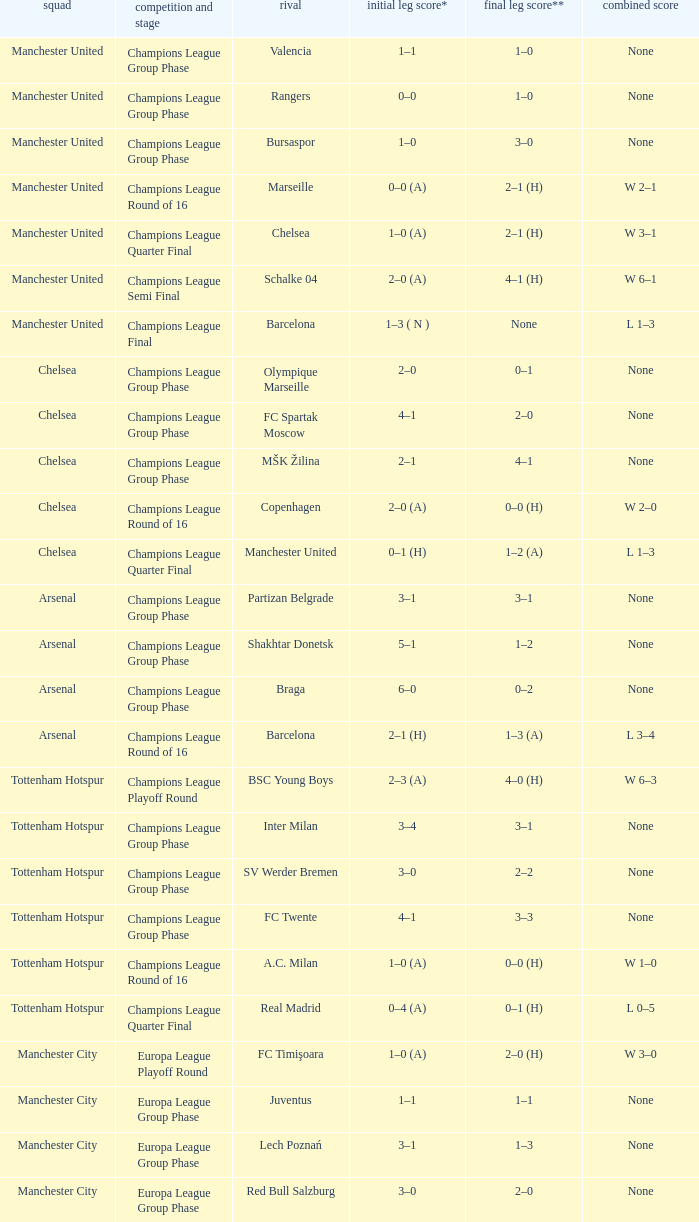Would you mind parsing the complete table? {'header': ['squad', 'competition and stage', 'rival', 'initial leg score*', 'final leg score**', 'combined score'], 'rows': [['Manchester United', 'Champions League Group Phase', 'Valencia', '1–1', '1–0', 'None'], ['Manchester United', 'Champions League Group Phase', 'Rangers', '0–0', '1–0', 'None'], ['Manchester United', 'Champions League Group Phase', 'Bursaspor', '1–0', '3–0', 'None'], ['Manchester United', 'Champions League Round of 16', 'Marseille', '0–0 (A)', '2–1 (H)', 'W 2–1'], ['Manchester United', 'Champions League Quarter Final', 'Chelsea', '1–0 (A)', '2–1 (H)', 'W 3–1'], ['Manchester United', 'Champions League Semi Final', 'Schalke 04', '2–0 (A)', '4–1 (H)', 'W 6–1'], ['Manchester United', 'Champions League Final', 'Barcelona', '1–3 ( N )', 'None', 'L 1–3'], ['Chelsea', 'Champions League Group Phase', 'Olympique Marseille', '2–0', '0–1', 'None'], ['Chelsea', 'Champions League Group Phase', 'FC Spartak Moscow', '4–1', '2–0', 'None'], ['Chelsea', 'Champions League Group Phase', 'MŠK Žilina', '2–1', '4–1', 'None'], ['Chelsea', 'Champions League Round of 16', 'Copenhagen', '2–0 (A)', '0–0 (H)', 'W 2–0'], ['Chelsea', 'Champions League Quarter Final', 'Manchester United', '0–1 (H)', '1–2 (A)', 'L 1–3'], ['Arsenal', 'Champions League Group Phase', 'Partizan Belgrade', '3–1', '3–1', 'None'], ['Arsenal', 'Champions League Group Phase', 'Shakhtar Donetsk', '5–1', '1–2', 'None'], ['Arsenal', 'Champions League Group Phase', 'Braga', '6–0', '0–2', 'None'], ['Arsenal', 'Champions League Round of 16', 'Barcelona', '2–1 (H)', '1–3 (A)', 'L 3–4'], ['Tottenham Hotspur', 'Champions League Playoff Round', 'BSC Young Boys', '2–3 (A)', '4–0 (H)', 'W 6–3'], ['Tottenham Hotspur', 'Champions League Group Phase', 'Inter Milan', '3–4', '3–1', 'None'], ['Tottenham Hotspur', 'Champions League Group Phase', 'SV Werder Bremen', '3–0', '2–2', 'None'], ['Tottenham Hotspur', 'Champions League Group Phase', 'FC Twente', '4–1', '3–3', 'None'], ['Tottenham Hotspur', 'Champions League Round of 16', 'A.C. Milan', '1–0 (A)', '0–0 (H)', 'W 1–0'], ['Tottenham Hotspur', 'Champions League Quarter Final', 'Real Madrid', '0–4 (A)', '0–1 (H)', 'L 0–5'], ['Manchester City', 'Europa League Playoff Round', 'FC Timişoara', '1–0 (A)', '2–0 (H)', 'W 3–0'], ['Manchester City', 'Europa League Group Phase', 'Juventus', '1–1', '1–1', 'None'], ['Manchester City', 'Europa League Group Phase', 'Lech Poznań', '3–1', '1–3', 'None'], ['Manchester City', 'Europa League Group Phase', 'Red Bull Salzburg', '3–0', '2–0', 'None'], ['Manchester City', 'Europa League Round of 32', 'Aris', '0–0 (A)', '3–0 (H)', 'W 3–0'], ['Manchester City', 'Europa League Round of 16', 'Dynamio Kyiv', '0–2 (A)', '1–0 (H)', 'L 1–2'], ['Aston Villa', 'Europa League Playoff Round', 'SK Rapid Wien', '1–1 (A)', '2–3 (H)', 'L 3–4'], ['Liverpool', 'Europa League 3rd Qual. Round', 'FK Rabotnički', '2–0 (A)', '2–0 (H)', 'W 4–0'], ['Liverpool', 'Europa League Playoff Round', 'Trabzonspor', '1–0 (H)', '2–1 (A)', 'W 3–1'], ['Liverpool', 'Europa League Group Phase', 'Napoli', '3–1', '0–0', 'None'], ['Liverpool', 'Europa League Group Phase', 'Steaua Bucureşti', '4–1', '1–1', 'None'], ['Liverpool', 'Europa League Group Phase', 'Utrecht', '0–0', '0–0', 'None'], ['Liverpool', 'Europa League Round of 32', 'Sparta Prague', '0–0 (A)', '1–0 (H)', 'W 1–0']]} How many goals did each one of the teams score in the first leg of the match between Liverpool and Trabzonspor? 1–0 (H). 